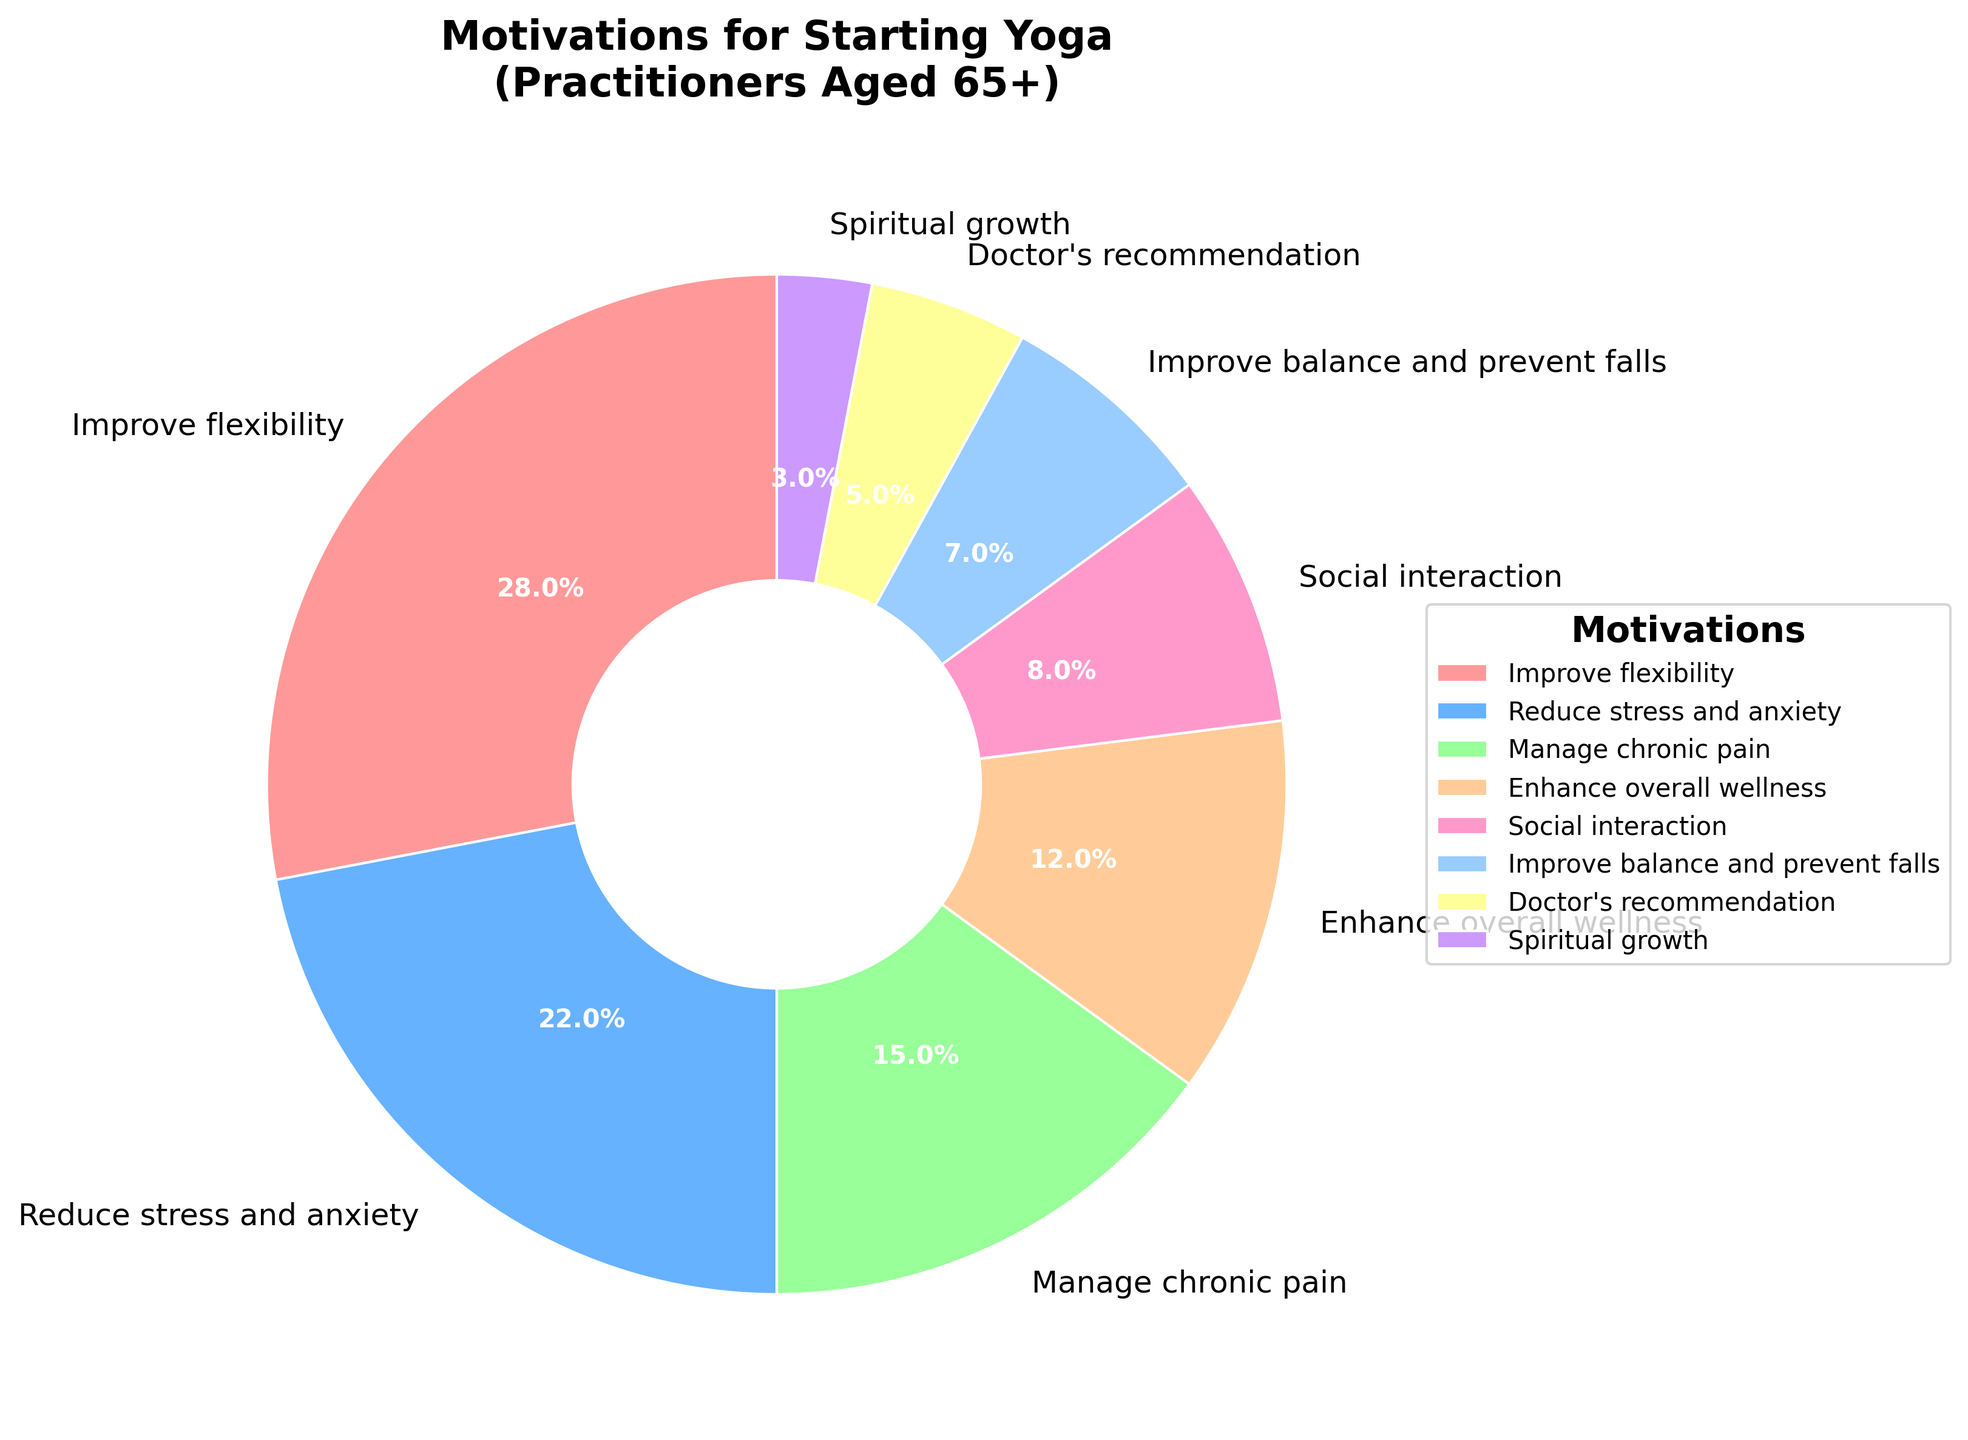What is the most common motivation for starting yoga among practitioners aged 65 and above? The largest slice of the pie chart indicates the most common motivation. According to the figure, the "Improve flexibility" category has the largest percentage.
Answer: Improve flexibility Which motivation has the smallest percentage? The smallest slice of the pie chart represents the motivation with the smallest percentage. In the figure, "Spiritual growth" has the smallest slice.
Answer: Spiritual growth What is the total percentage of practitioners motivated by 'Reduce stress and anxiety' and 'Manage chronic pain'? Sum the percentages for 'Reduce stress and anxiety' and 'Manage chronic pain'. The percentages are 22% and 15%, respectively. 22 + 15 = 37%.
Answer: 37% How many motivations have a percentage higher than 10%? Count the number of slices with percentages greater than 10%. The categories are 'Improve flexibility' (28%), 'Reduce stress and anxiety' (22%), and 'Manage chronic pain' (15%). There are 3 such motivations.
Answer: 3 How does the percentage for 'Improve balance and prevent falls' compare to 'Doctor's recommendation'? Compare the percentages of both motivations. 'Improve balance and prevent falls' has 7%, while 'Doctor's recommendation' has 5%. 7% is greater than 5%.
Answer: Improve balance and prevent falls (7%) is greater than Doctor's recommendation (5%) What is the difference in percentage between 'Social interaction' and 'Enhance overall wellness'? Subtract the percentage of 'Enhance overall wellness' from 'Social interaction'. 'Social interaction' has 8% and 'Enhance overall wellness' has 12%. The difference is 12 - 8 = 4%.
Answer: 4% Which motivation has a green-colored slice in the pie chart? Observe the colors used in the chart. According to the custom colors used, the green slice corresponds to 'Manage chronic pain'.
Answer: Manage chronic pain If you combined the percentages of 'Doctor's recommendation' and 'Spiritual growth', would it exceed the percentage of 'Social interaction'? Add the percentages of 'Doctor's recommendation' and 'Spiritual growth': 5% + 3% = 8%. Compare this to 'Social interaction', which is also 8%. The total is equal to 8%.
Answer: No, it would be equal (8%) What are the visual differences between the slices representing 'Enhance overall wellness' and 'Improve balance and prevent falls'? 'Enhance overall wellness' has a larger slice compared to 'Improve balance and prevent falls'. Observing the colors, 'Enhance overall wellness' is represented by a peach-like color, while 'Improve balance and prevent falls' is in a pinkish-purplish color.
Answer: 'Enhance overall wellness' is larger and peach-colored; 'Improve balance and prevent falls' is smaller and pinkish-purplish 